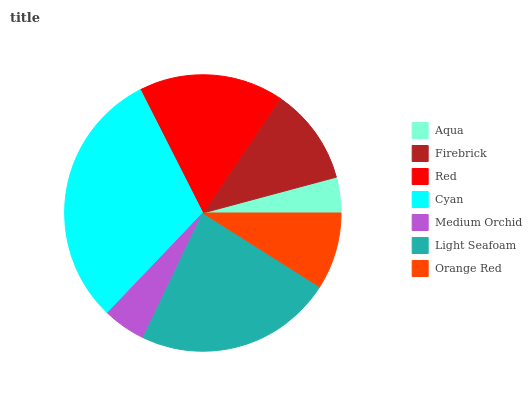Is Aqua the minimum?
Answer yes or no. Yes. Is Cyan the maximum?
Answer yes or no. Yes. Is Firebrick the minimum?
Answer yes or no. No. Is Firebrick the maximum?
Answer yes or no. No. Is Firebrick greater than Aqua?
Answer yes or no. Yes. Is Aqua less than Firebrick?
Answer yes or no. Yes. Is Aqua greater than Firebrick?
Answer yes or no. No. Is Firebrick less than Aqua?
Answer yes or no. No. Is Firebrick the high median?
Answer yes or no. Yes. Is Firebrick the low median?
Answer yes or no. Yes. Is Cyan the high median?
Answer yes or no. No. Is Red the low median?
Answer yes or no. No. 